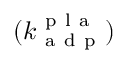Convert formula to latex. <formula><loc_0><loc_0><loc_500><loc_500>( k _ { a d p } ^ { p l a } )</formula> 